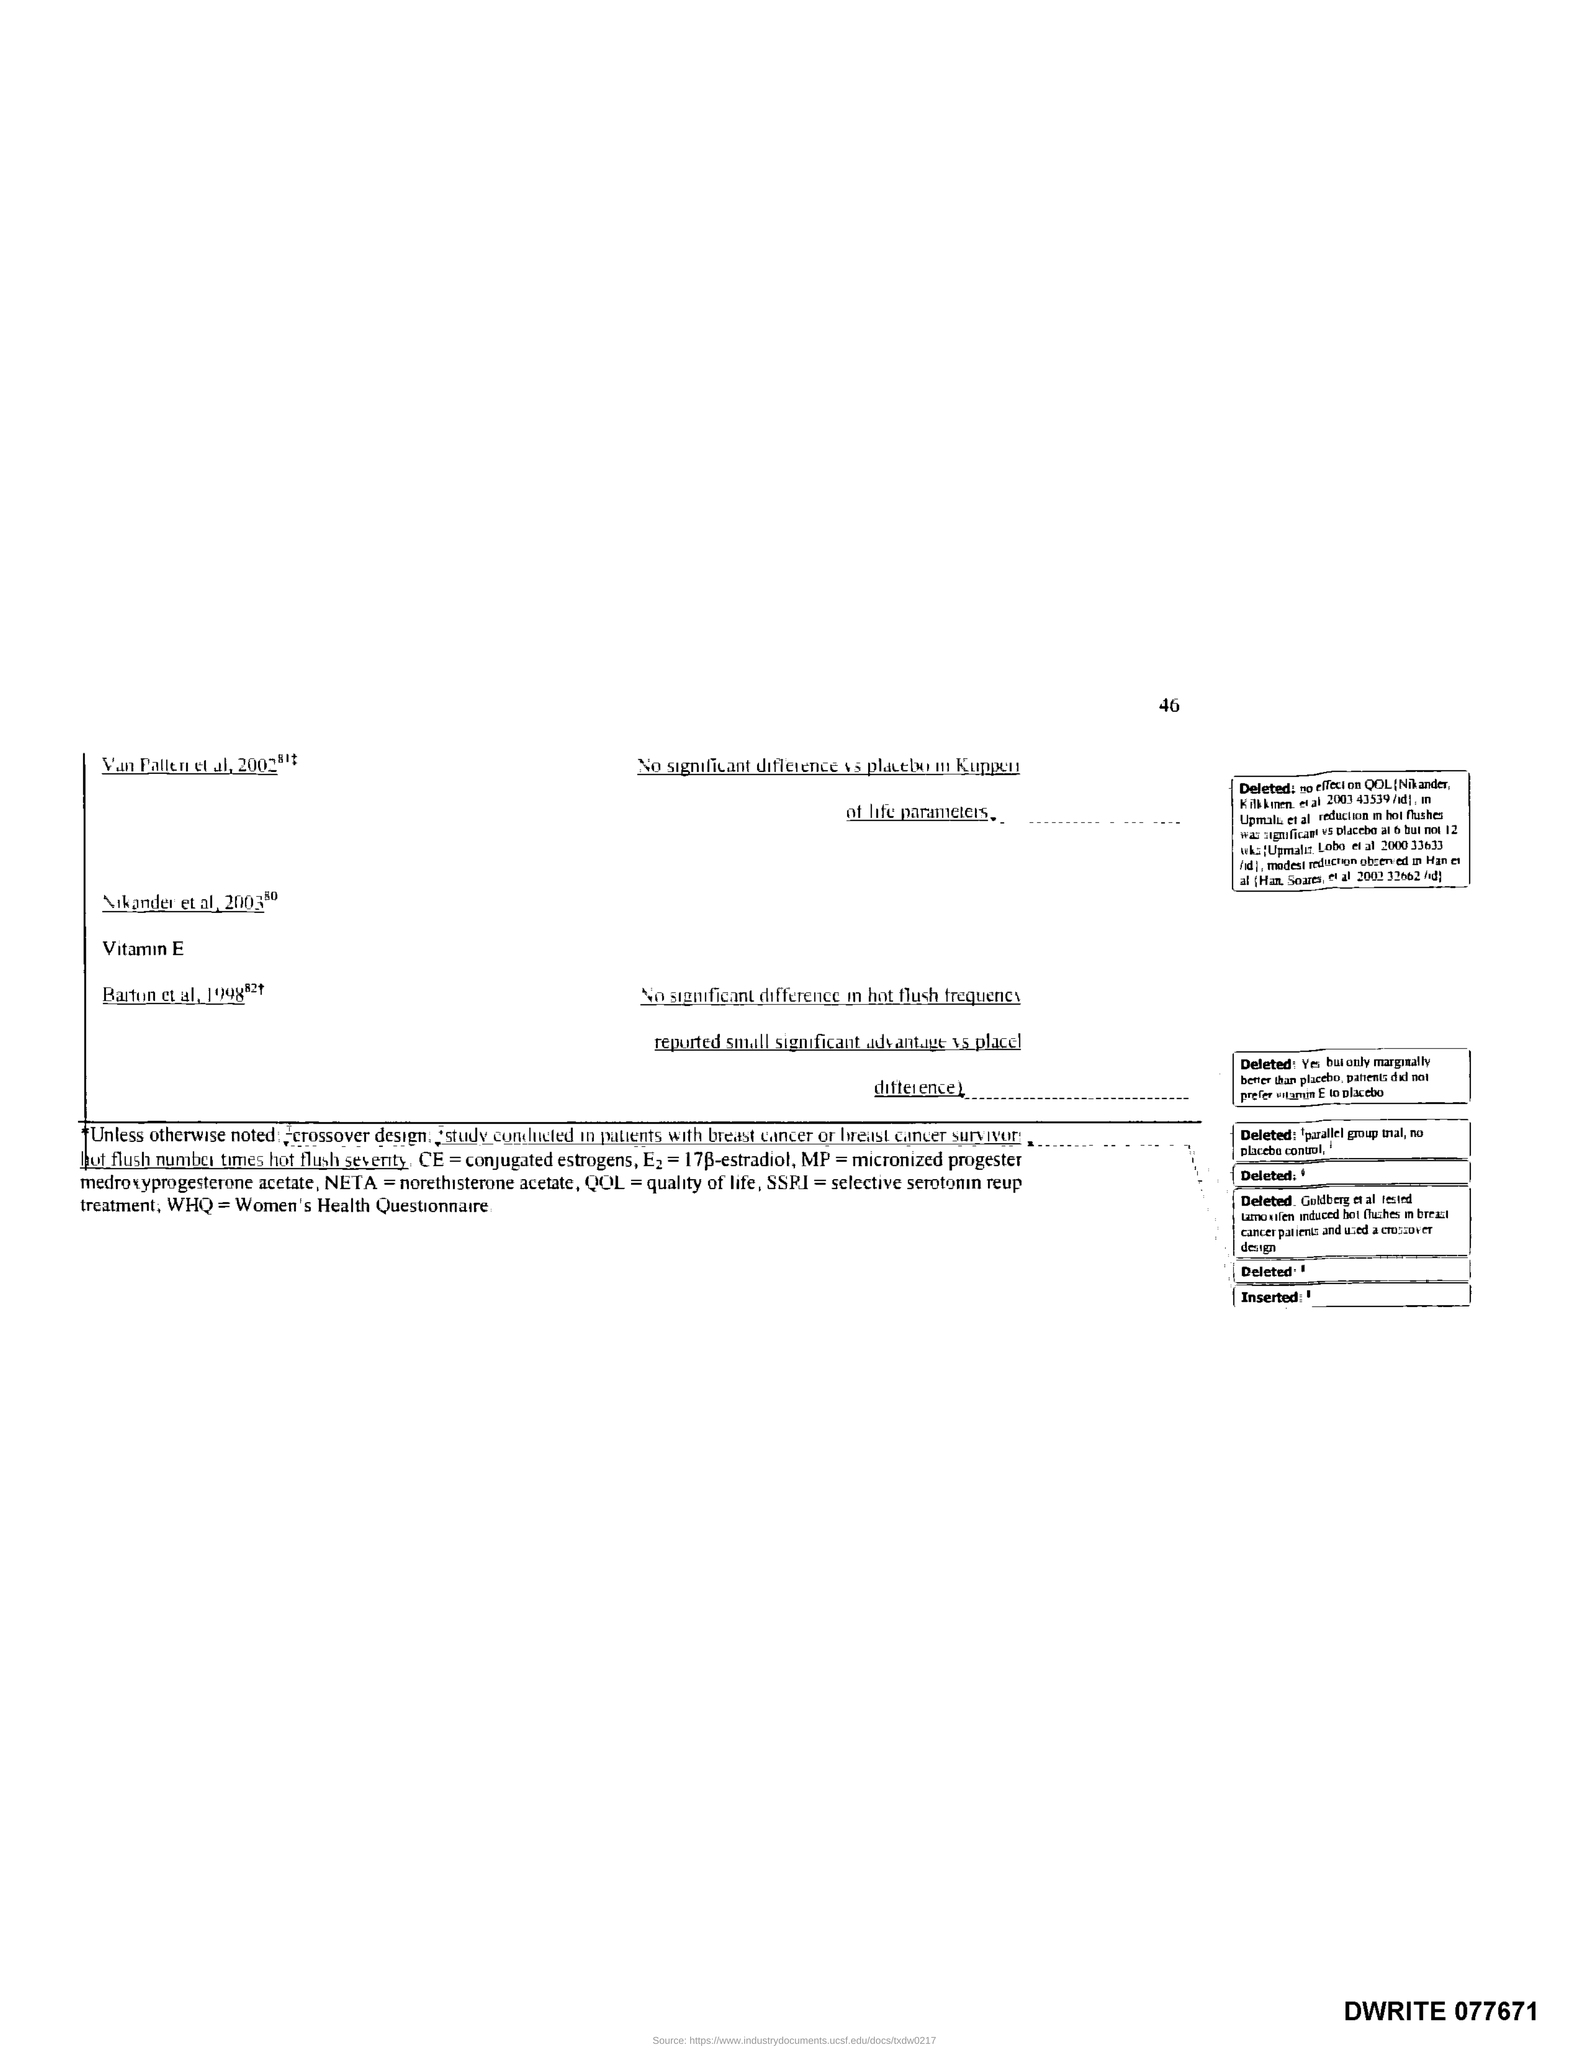Indicate a few pertinent items in this graphic. The page number is 46. 